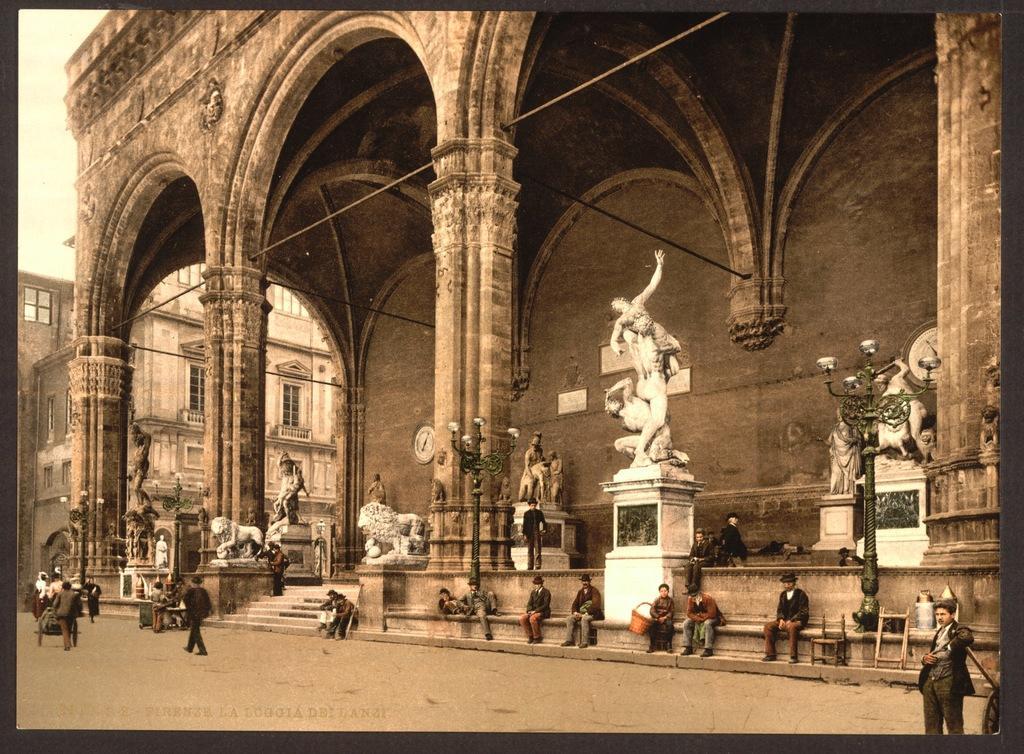In one or two sentences, can you explain what this image depicts? In the center of the image there are buildings. There are statues. There are people sitting. At the bottom of the image there is road. There are people walking. 